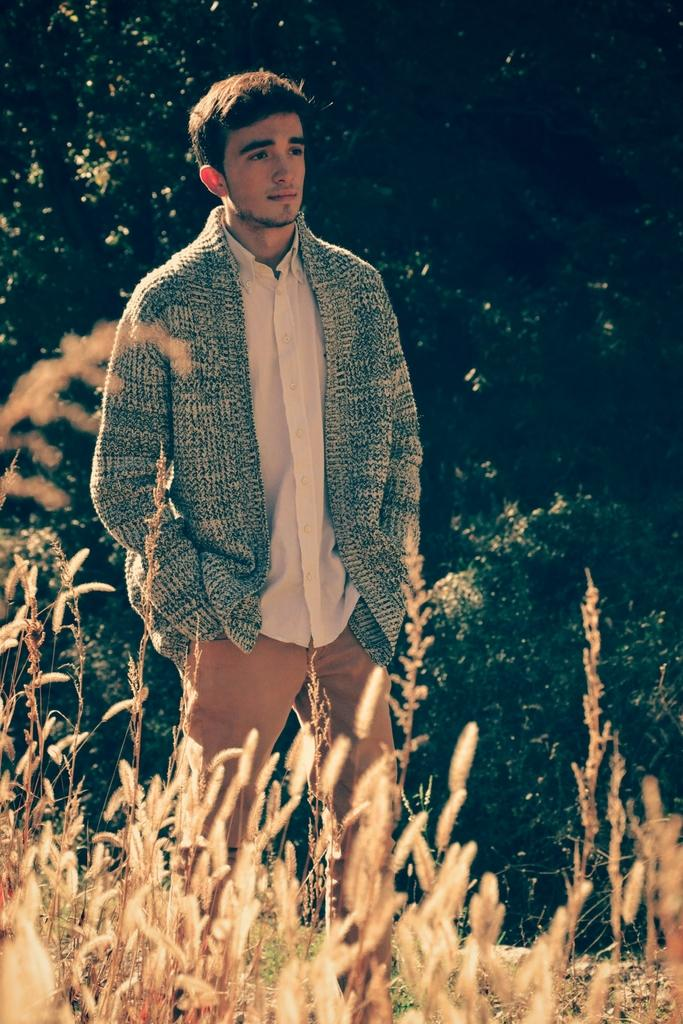What is the main subject of the image? There is a person standing in the center of the image. What is the person standing on? The person is standing on the grass. What can be seen in the background of the image? There are trees in the background of the image. What type of vegetation is visible at the bottom of the image? Plants are visible at the bottom of the image. What type of apparel is the fireman wearing in the image? There is no fireman present in the image, and therefore no apparel can be described. 